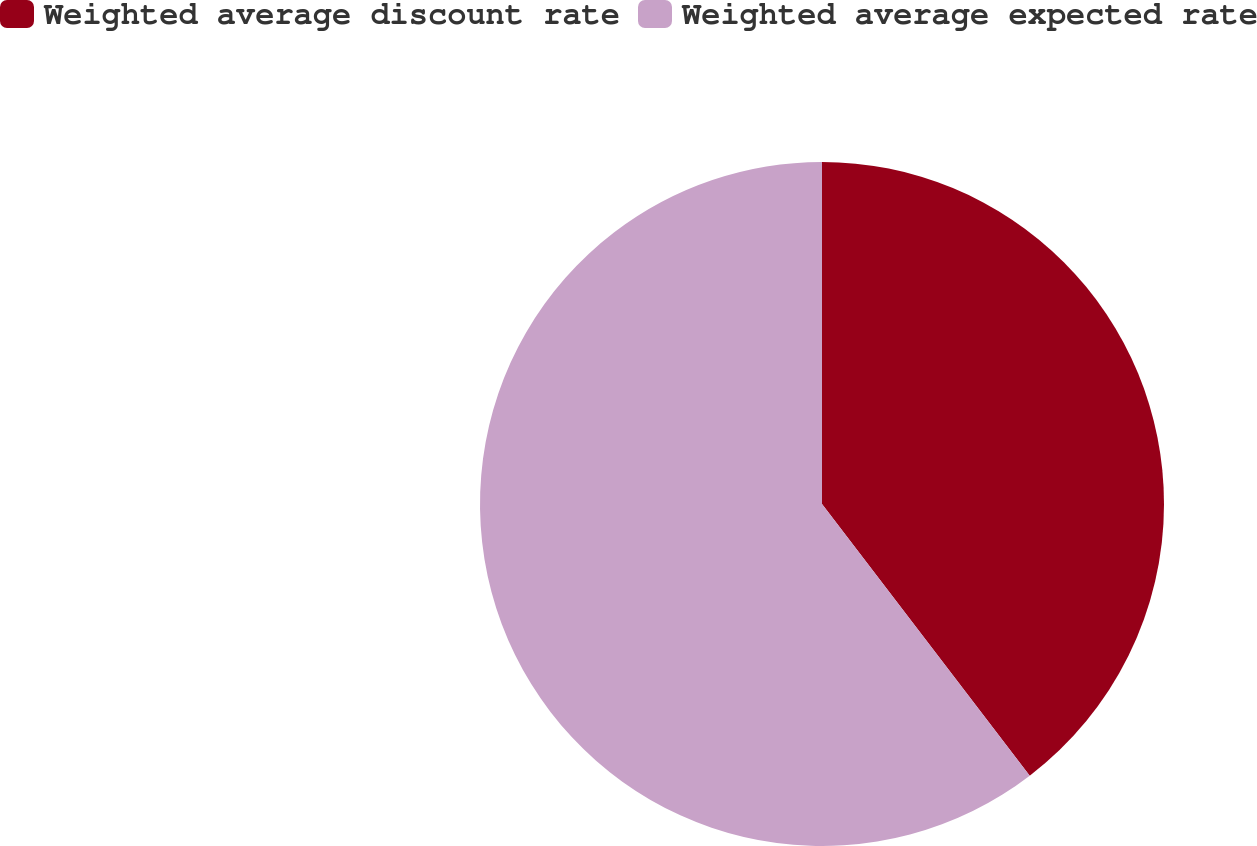Convert chart to OTSL. <chart><loc_0><loc_0><loc_500><loc_500><pie_chart><fcel>Weighted average discount rate<fcel>Weighted average expected rate<nl><fcel>39.61%<fcel>60.39%<nl></chart> 